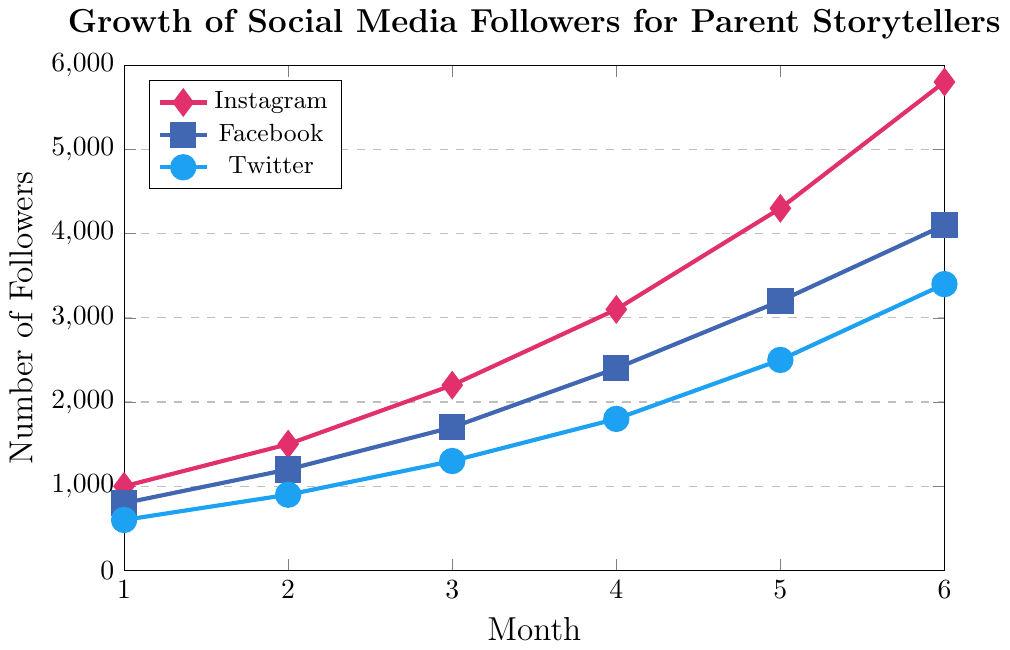Which platform had the highest increase in followers by Month 6? Instagram had 5800 followers by Month 6, Facebook had 4100, and Twitter had 3400. By comparing these numbers, Instagram had the highest follower count.
Answer: Instagram How many total followers did Instagram gain from Month 1 to Month 6? Instagram followers grew from 1000 in Month 1 to 5800 in Month 6. The increase is calculated as 5800 - 1000.
Answer: 4800 What is the average number of Twitter followers over the 6 months? Add the number of Twitter followers from Month 1 to Month 6 (600 + 900 + 1300 + 1800 + 2500 + 3400) which equals 10500. Divide by 6 to get the average.
Answer: 1750 Which platform showed the smallest growth between Month 3 and Month 4? Instagram increased from 2200 to 3100 (an increase of 900), Facebook increased from 1700 to 2400 (an increase of 700), Twitter increased from 1300 to 1800 (an increase of 500). Twitter had the smallest growth.
Answer: Twitter Which month had the highest follower increase for Instagram? The increases for Instagram followers are: Month 1 to 2: 500, Month 2 to 3: 700, Month 3 to 4: 900, Month 4 to 5: 1200, Month 5 to 6: 1500. The highest increase is from Month 5 to 6 with 1500.
Answer: Month 6 Compare the total number of followers across all platforms by Month 4. Which has the most followers? By Month 4: Instagram has 3100, Facebook has 2400, Twitter has 1800. Instagram has the most followers by Month 4.
Answer: Instagram By how much did Facebook's followers increase from Month 5 to Month 6? Facebook followers grew from 3200 in Month 5 to 4100 in Month 6. The increase is 4100 - 3200.
Answer: 900 What is the total number of followers across all platforms in Month 2? Instagram has 1500 followers, Facebook has 1200 followers, Twitter has 900 followers in Month 2. The total is 1500 + 1200 + 900.
Answer: 3600 At which month did the combined number of followers for Facebook and Twitter first exceed Instagram's followers? Combine Facebook and Twitter followers each month and compare to Instagram: Month 1: 800 + 600 = 1400 < 1000, Month 2: 1200 + 900 = 2100 > 1500. This occurs first in Month 2.
Answer: Month 2 